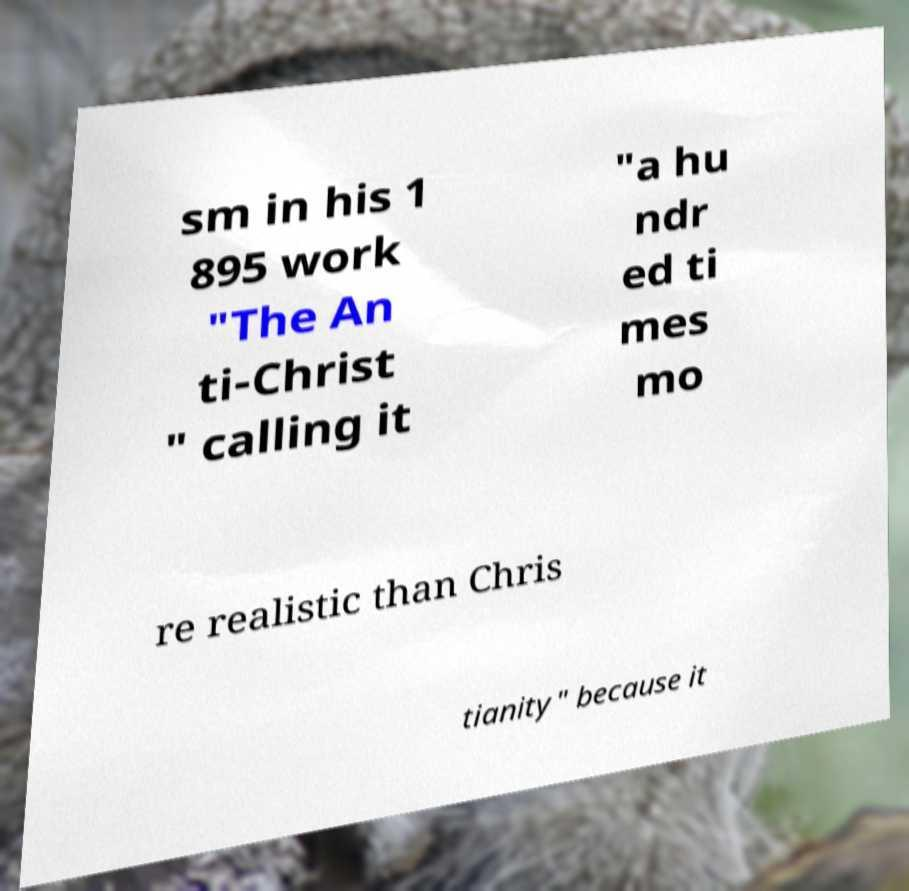There's text embedded in this image that I need extracted. Can you transcribe it verbatim? sm in his 1 895 work "The An ti-Christ " calling it "a hu ndr ed ti mes mo re realistic than Chris tianity" because it 